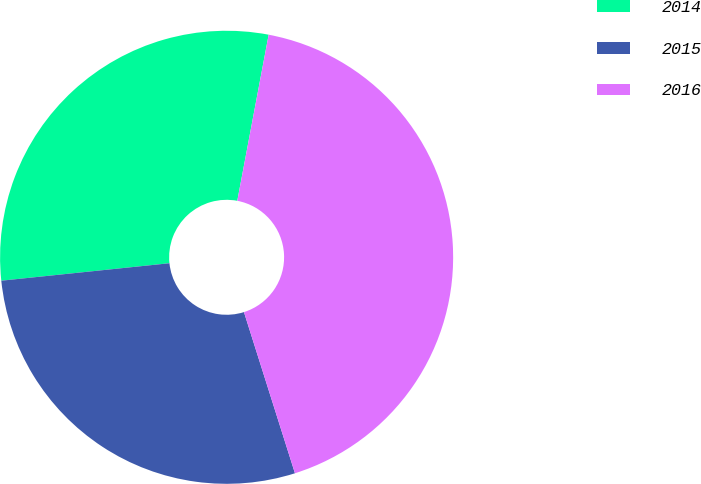Convert chart. <chart><loc_0><loc_0><loc_500><loc_500><pie_chart><fcel>2014<fcel>2015<fcel>2016<nl><fcel>29.62%<fcel>28.23%<fcel>42.15%<nl></chart> 